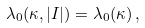Convert formula to latex. <formula><loc_0><loc_0><loc_500><loc_500>\lambda _ { 0 } ( \kappa , | I | ) = \lambda _ { 0 } ( \kappa ) \, ,</formula> 